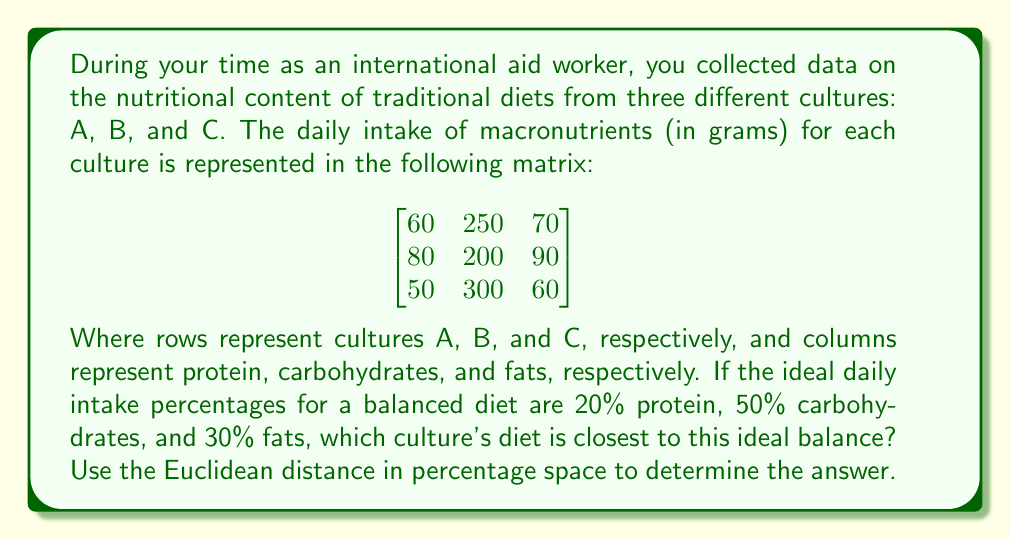Provide a solution to this math problem. To solve this problem, we'll follow these steps:

1) First, calculate the total grams of macronutrients for each culture:
   Culture A: $60 + 250 + 70 = 380$ g
   Culture B: $80 + 200 + 90 = 370$ g
   Culture C: $50 + 300 + 60 = 410$ g

2) Convert the gram values to percentages for each culture:
   Culture A: $(15.79\%, 65.79\%, 18.42\%)$
   Culture B: $(21.62\%, 54.05\%, 24.32\%)$
   Culture C: $(12.20\%, 73.17\%, 14.63\%)$

3) The ideal percentages are $(20\%, 50\%, 30\%)$

4) Calculate the Euclidean distance between each culture's percentages and the ideal:

   For Culture A:
   $$d_A = \sqrt{(20-15.79)^2 + (50-65.79)^2 + (30-18.42)^2} = 18.95$$

   For Culture B:
   $$d_B = \sqrt{(20-21.62)^2 + (50-54.05)^2 + (30-24.32)^2} = 6.95$$

   For Culture C:
   $$d_C = \sqrt{(20-12.20)^2 + (50-73.17)^2 + (30-14.63)^2} = 27.22$$

5) The culture with the smallest Euclidean distance is closest to the ideal balance.
Answer: Culture B 